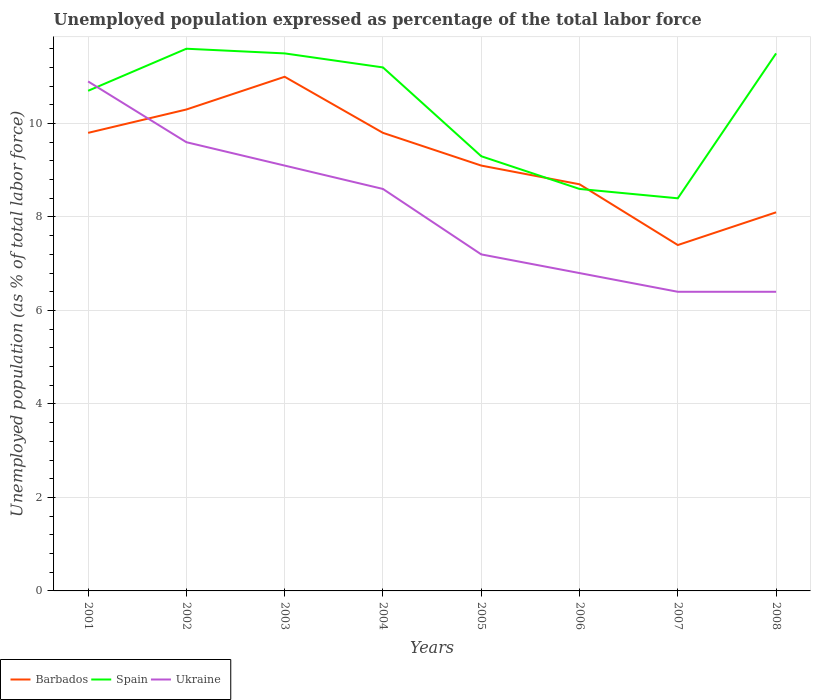How many different coloured lines are there?
Provide a succinct answer. 3. Does the line corresponding to Spain intersect with the line corresponding to Ukraine?
Give a very brief answer. Yes. Is the number of lines equal to the number of legend labels?
Your answer should be very brief. Yes. Across all years, what is the maximum unemployment in in Spain?
Provide a succinct answer. 8.4. What is the total unemployment in in Ukraine in the graph?
Ensure brevity in your answer.  4.5. What is the difference between the highest and the second highest unemployment in in Ukraine?
Your answer should be very brief. 4.5. What is the difference between two consecutive major ticks on the Y-axis?
Your answer should be compact. 2. Are the values on the major ticks of Y-axis written in scientific E-notation?
Offer a terse response. No. Does the graph contain any zero values?
Provide a succinct answer. No. Does the graph contain grids?
Your response must be concise. Yes. How are the legend labels stacked?
Offer a very short reply. Horizontal. What is the title of the graph?
Your response must be concise. Unemployed population expressed as percentage of the total labor force. Does "East Asia (developing only)" appear as one of the legend labels in the graph?
Provide a short and direct response. No. What is the label or title of the X-axis?
Give a very brief answer. Years. What is the label or title of the Y-axis?
Make the answer very short. Unemployed population (as % of total labor force). What is the Unemployed population (as % of total labor force) of Barbados in 2001?
Make the answer very short. 9.8. What is the Unemployed population (as % of total labor force) in Spain in 2001?
Your response must be concise. 10.7. What is the Unemployed population (as % of total labor force) of Ukraine in 2001?
Make the answer very short. 10.9. What is the Unemployed population (as % of total labor force) of Barbados in 2002?
Provide a succinct answer. 10.3. What is the Unemployed population (as % of total labor force) of Spain in 2002?
Give a very brief answer. 11.6. What is the Unemployed population (as % of total labor force) of Ukraine in 2002?
Your answer should be compact. 9.6. What is the Unemployed population (as % of total labor force) of Ukraine in 2003?
Offer a terse response. 9.1. What is the Unemployed population (as % of total labor force) of Barbados in 2004?
Your response must be concise. 9.8. What is the Unemployed population (as % of total labor force) in Spain in 2004?
Provide a succinct answer. 11.2. What is the Unemployed population (as % of total labor force) of Ukraine in 2004?
Give a very brief answer. 8.6. What is the Unemployed population (as % of total labor force) of Barbados in 2005?
Keep it short and to the point. 9.1. What is the Unemployed population (as % of total labor force) of Spain in 2005?
Provide a short and direct response. 9.3. What is the Unemployed population (as % of total labor force) in Ukraine in 2005?
Provide a succinct answer. 7.2. What is the Unemployed population (as % of total labor force) in Barbados in 2006?
Offer a terse response. 8.7. What is the Unemployed population (as % of total labor force) in Spain in 2006?
Provide a short and direct response. 8.6. What is the Unemployed population (as % of total labor force) of Ukraine in 2006?
Ensure brevity in your answer.  6.8. What is the Unemployed population (as % of total labor force) in Barbados in 2007?
Provide a succinct answer. 7.4. What is the Unemployed population (as % of total labor force) in Spain in 2007?
Make the answer very short. 8.4. What is the Unemployed population (as % of total labor force) in Ukraine in 2007?
Provide a short and direct response. 6.4. What is the Unemployed population (as % of total labor force) of Barbados in 2008?
Give a very brief answer. 8.1. What is the Unemployed population (as % of total labor force) in Ukraine in 2008?
Offer a terse response. 6.4. Across all years, what is the maximum Unemployed population (as % of total labor force) of Spain?
Your answer should be very brief. 11.6. Across all years, what is the maximum Unemployed population (as % of total labor force) in Ukraine?
Keep it short and to the point. 10.9. Across all years, what is the minimum Unemployed population (as % of total labor force) of Barbados?
Keep it short and to the point. 7.4. Across all years, what is the minimum Unemployed population (as % of total labor force) in Spain?
Your answer should be compact. 8.4. Across all years, what is the minimum Unemployed population (as % of total labor force) in Ukraine?
Make the answer very short. 6.4. What is the total Unemployed population (as % of total labor force) of Barbados in the graph?
Your answer should be very brief. 74.2. What is the total Unemployed population (as % of total labor force) in Spain in the graph?
Provide a short and direct response. 82.8. What is the difference between the Unemployed population (as % of total labor force) in Barbados in 2001 and that in 2002?
Offer a terse response. -0.5. What is the difference between the Unemployed population (as % of total labor force) of Spain in 2001 and that in 2002?
Your response must be concise. -0.9. What is the difference between the Unemployed population (as % of total labor force) in Ukraine in 2001 and that in 2002?
Provide a short and direct response. 1.3. What is the difference between the Unemployed population (as % of total labor force) of Barbados in 2001 and that in 2003?
Your response must be concise. -1.2. What is the difference between the Unemployed population (as % of total labor force) in Barbados in 2001 and that in 2004?
Provide a short and direct response. 0. What is the difference between the Unemployed population (as % of total labor force) of Spain in 2001 and that in 2004?
Provide a short and direct response. -0.5. What is the difference between the Unemployed population (as % of total labor force) of Barbados in 2001 and that in 2005?
Make the answer very short. 0.7. What is the difference between the Unemployed population (as % of total labor force) of Spain in 2001 and that in 2005?
Offer a terse response. 1.4. What is the difference between the Unemployed population (as % of total labor force) of Ukraine in 2001 and that in 2005?
Your response must be concise. 3.7. What is the difference between the Unemployed population (as % of total labor force) of Barbados in 2001 and that in 2006?
Provide a short and direct response. 1.1. What is the difference between the Unemployed population (as % of total labor force) in Spain in 2001 and that in 2006?
Ensure brevity in your answer.  2.1. What is the difference between the Unemployed population (as % of total labor force) in Ukraine in 2001 and that in 2007?
Make the answer very short. 4.5. What is the difference between the Unemployed population (as % of total labor force) in Ukraine in 2001 and that in 2008?
Offer a terse response. 4.5. What is the difference between the Unemployed population (as % of total labor force) in Spain in 2002 and that in 2003?
Offer a terse response. 0.1. What is the difference between the Unemployed population (as % of total labor force) in Barbados in 2002 and that in 2004?
Ensure brevity in your answer.  0.5. What is the difference between the Unemployed population (as % of total labor force) of Spain in 2002 and that in 2004?
Your answer should be compact. 0.4. What is the difference between the Unemployed population (as % of total labor force) in Ukraine in 2002 and that in 2004?
Offer a terse response. 1. What is the difference between the Unemployed population (as % of total labor force) in Spain in 2002 and that in 2005?
Your answer should be very brief. 2.3. What is the difference between the Unemployed population (as % of total labor force) of Ukraine in 2002 and that in 2005?
Your answer should be compact. 2.4. What is the difference between the Unemployed population (as % of total labor force) in Barbados in 2002 and that in 2006?
Your response must be concise. 1.6. What is the difference between the Unemployed population (as % of total labor force) of Ukraine in 2002 and that in 2006?
Offer a very short reply. 2.8. What is the difference between the Unemployed population (as % of total labor force) of Spain in 2002 and that in 2007?
Give a very brief answer. 3.2. What is the difference between the Unemployed population (as % of total labor force) of Ukraine in 2002 and that in 2007?
Keep it short and to the point. 3.2. What is the difference between the Unemployed population (as % of total labor force) in Spain in 2002 and that in 2008?
Provide a succinct answer. 0.1. What is the difference between the Unemployed population (as % of total labor force) in Ukraine in 2003 and that in 2004?
Provide a short and direct response. 0.5. What is the difference between the Unemployed population (as % of total labor force) of Barbados in 2003 and that in 2005?
Provide a succinct answer. 1.9. What is the difference between the Unemployed population (as % of total labor force) of Ukraine in 2003 and that in 2006?
Ensure brevity in your answer.  2.3. What is the difference between the Unemployed population (as % of total labor force) of Ukraine in 2003 and that in 2007?
Give a very brief answer. 2.7. What is the difference between the Unemployed population (as % of total labor force) in Ukraine in 2003 and that in 2008?
Provide a succinct answer. 2.7. What is the difference between the Unemployed population (as % of total labor force) in Barbados in 2004 and that in 2006?
Give a very brief answer. 1.1. What is the difference between the Unemployed population (as % of total labor force) in Spain in 2004 and that in 2006?
Offer a terse response. 2.6. What is the difference between the Unemployed population (as % of total labor force) in Barbados in 2004 and that in 2007?
Your answer should be compact. 2.4. What is the difference between the Unemployed population (as % of total labor force) of Spain in 2004 and that in 2007?
Keep it short and to the point. 2.8. What is the difference between the Unemployed population (as % of total labor force) in Barbados in 2004 and that in 2008?
Offer a terse response. 1.7. What is the difference between the Unemployed population (as % of total labor force) in Ukraine in 2004 and that in 2008?
Keep it short and to the point. 2.2. What is the difference between the Unemployed population (as % of total labor force) in Spain in 2005 and that in 2006?
Give a very brief answer. 0.7. What is the difference between the Unemployed population (as % of total labor force) of Ukraine in 2005 and that in 2007?
Provide a short and direct response. 0.8. What is the difference between the Unemployed population (as % of total labor force) in Barbados in 2006 and that in 2008?
Provide a short and direct response. 0.6. What is the difference between the Unemployed population (as % of total labor force) in Ukraine in 2006 and that in 2008?
Offer a terse response. 0.4. What is the difference between the Unemployed population (as % of total labor force) in Barbados in 2007 and that in 2008?
Offer a very short reply. -0.7. What is the difference between the Unemployed population (as % of total labor force) of Spain in 2007 and that in 2008?
Provide a short and direct response. -3.1. What is the difference between the Unemployed population (as % of total labor force) in Barbados in 2001 and the Unemployed population (as % of total labor force) in Spain in 2002?
Offer a terse response. -1.8. What is the difference between the Unemployed population (as % of total labor force) in Barbados in 2001 and the Unemployed population (as % of total labor force) in Ukraine in 2003?
Keep it short and to the point. 0.7. What is the difference between the Unemployed population (as % of total labor force) in Spain in 2001 and the Unemployed population (as % of total labor force) in Ukraine in 2003?
Offer a very short reply. 1.6. What is the difference between the Unemployed population (as % of total labor force) in Barbados in 2001 and the Unemployed population (as % of total labor force) in Ukraine in 2004?
Your response must be concise. 1.2. What is the difference between the Unemployed population (as % of total labor force) in Spain in 2001 and the Unemployed population (as % of total labor force) in Ukraine in 2004?
Give a very brief answer. 2.1. What is the difference between the Unemployed population (as % of total labor force) in Barbados in 2001 and the Unemployed population (as % of total labor force) in Spain in 2005?
Ensure brevity in your answer.  0.5. What is the difference between the Unemployed population (as % of total labor force) in Barbados in 2001 and the Unemployed population (as % of total labor force) in Ukraine in 2005?
Your answer should be very brief. 2.6. What is the difference between the Unemployed population (as % of total labor force) of Spain in 2001 and the Unemployed population (as % of total labor force) of Ukraine in 2005?
Your answer should be very brief. 3.5. What is the difference between the Unemployed population (as % of total labor force) of Spain in 2001 and the Unemployed population (as % of total labor force) of Ukraine in 2006?
Keep it short and to the point. 3.9. What is the difference between the Unemployed population (as % of total labor force) of Spain in 2001 and the Unemployed population (as % of total labor force) of Ukraine in 2007?
Offer a very short reply. 4.3. What is the difference between the Unemployed population (as % of total labor force) in Barbados in 2001 and the Unemployed population (as % of total labor force) in Ukraine in 2008?
Give a very brief answer. 3.4. What is the difference between the Unemployed population (as % of total labor force) of Barbados in 2002 and the Unemployed population (as % of total labor force) of Ukraine in 2003?
Give a very brief answer. 1.2. What is the difference between the Unemployed population (as % of total labor force) in Barbados in 2002 and the Unemployed population (as % of total labor force) in Spain in 2004?
Your answer should be very brief. -0.9. What is the difference between the Unemployed population (as % of total labor force) of Barbados in 2002 and the Unemployed population (as % of total labor force) of Ukraine in 2004?
Offer a very short reply. 1.7. What is the difference between the Unemployed population (as % of total labor force) of Spain in 2002 and the Unemployed population (as % of total labor force) of Ukraine in 2004?
Offer a very short reply. 3. What is the difference between the Unemployed population (as % of total labor force) of Barbados in 2002 and the Unemployed population (as % of total labor force) of Spain in 2005?
Your answer should be compact. 1. What is the difference between the Unemployed population (as % of total labor force) of Spain in 2002 and the Unemployed population (as % of total labor force) of Ukraine in 2005?
Offer a very short reply. 4.4. What is the difference between the Unemployed population (as % of total labor force) of Barbados in 2002 and the Unemployed population (as % of total labor force) of Ukraine in 2006?
Ensure brevity in your answer.  3.5. What is the difference between the Unemployed population (as % of total labor force) in Spain in 2002 and the Unemployed population (as % of total labor force) in Ukraine in 2007?
Your answer should be very brief. 5.2. What is the difference between the Unemployed population (as % of total labor force) of Barbados in 2002 and the Unemployed population (as % of total labor force) of Ukraine in 2008?
Your answer should be very brief. 3.9. What is the difference between the Unemployed population (as % of total labor force) of Spain in 2002 and the Unemployed population (as % of total labor force) of Ukraine in 2008?
Keep it short and to the point. 5.2. What is the difference between the Unemployed population (as % of total labor force) in Barbados in 2003 and the Unemployed population (as % of total labor force) in Ukraine in 2004?
Your answer should be compact. 2.4. What is the difference between the Unemployed population (as % of total labor force) of Spain in 2003 and the Unemployed population (as % of total labor force) of Ukraine in 2004?
Your response must be concise. 2.9. What is the difference between the Unemployed population (as % of total labor force) of Barbados in 2003 and the Unemployed population (as % of total labor force) of Spain in 2005?
Ensure brevity in your answer.  1.7. What is the difference between the Unemployed population (as % of total labor force) of Barbados in 2003 and the Unemployed population (as % of total labor force) of Ukraine in 2005?
Offer a very short reply. 3.8. What is the difference between the Unemployed population (as % of total labor force) in Spain in 2003 and the Unemployed population (as % of total labor force) in Ukraine in 2005?
Give a very brief answer. 4.3. What is the difference between the Unemployed population (as % of total labor force) of Barbados in 2003 and the Unemployed population (as % of total labor force) of Spain in 2006?
Your answer should be compact. 2.4. What is the difference between the Unemployed population (as % of total labor force) of Spain in 2003 and the Unemployed population (as % of total labor force) of Ukraine in 2006?
Make the answer very short. 4.7. What is the difference between the Unemployed population (as % of total labor force) of Barbados in 2003 and the Unemployed population (as % of total labor force) of Ukraine in 2007?
Give a very brief answer. 4.6. What is the difference between the Unemployed population (as % of total labor force) of Barbados in 2003 and the Unemployed population (as % of total labor force) of Spain in 2008?
Offer a very short reply. -0.5. What is the difference between the Unemployed population (as % of total labor force) in Barbados in 2003 and the Unemployed population (as % of total labor force) in Ukraine in 2008?
Your answer should be very brief. 4.6. What is the difference between the Unemployed population (as % of total labor force) of Barbados in 2004 and the Unemployed population (as % of total labor force) of Ukraine in 2005?
Offer a very short reply. 2.6. What is the difference between the Unemployed population (as % of total labor force) of Barbados in 2004 and the Unemployed population (as % of total labor force) of Ukraine in 2006?
Your response must be concise. 3. What is the difference between the Unemployed population (as % of total labor force) of Spain in 2004 and the Unemployed population (as % of total labor force) of Ukraine in 2006?
Ensure brevity in your answer.  4.4. What is the difference between the Unemployed population (as % of total labor force) in Barbados in 2004 and the Unemployed population (as % of total labor force) in Spain in 2007?
Keep it short and to the point. 1.4. What is the difference between the Unemployed population (as % of total labor force) in Barbados in 2004 and the Unemployed population (as % of total labor force) in Ukraine in 2007?
Keep it short and to the point. 3.4. What is the difference between the Unemployed population (as % of total labor force) of Spain in 2004 and the Unemployed population (as % of total labor force) of Ukraine in 2007?
Offer a very short reply. 4.8. What is the difference between the Unemployed population (as % of total labor force) in Barbados in 2004 and the Unemployed population (as % of total labor force) in Ukraine in 2008?
Make the answer very short. 3.4. What is the difference between the Unemployed population (as % of total labor force) in Spain in 2004 and the Unemployed population (as % of total labor force) in Ukraine in 2008?
Provide a succinct answer. 4.8. What is the difference between the Unemployed population (as % of total labor force) in Barbados in 2005 and the Unemployed population (as % of total labor force) in Ukraine in 2006?
Your answer should be compact. 2.3. What is the difference between the Unemployed population (as % of total labor force) of Barbados in 2005 and the Unemployed population (as % of total labor force) of Spain in 2007?
Offer a terse response. 0.7. What is the difference between the Unemployed population (as % of total labor force) of Barbados in 2005 and the Unemployed population (as % of total labor force) of Ukraine in 2007?
Offer a terse response. 2.7. What is the difference between the Unemployed population (as % of total labor force) in Spain in 2005 and the Unemployed population (as % of total labor force) in Ukraine in 2007?
Ensure brevity in your answer.  2.9. What is the difference between the Unemployed population (as % of total labor force) in Barbados in 2005 and the Unemployed population (as % of total labor force) in Ukraine in 2008?
Your answer should be compact. 2.7. What is the difference between the Unemployed population (as % of total labor force) of Spain in 2006 and the Unemployed population (as % of total labor force) of Ukraine in 2007?
Your answer should be very brief. 2.2. What is the difference between the Unemployed population (as % of total labor force) of Barbados in 2007 and the Unemployed population (as % of total labor force) of Spain in 2008?
Make the answer very short. -4.1. What is the difference between the Unemployed population (as % of total labor force) of Barbados in 2007 and the Unemployed population (as % of total labor force) of Ukraine in 2008?
Provide a succinct answer. 1. What is the average Unemployed population (as % of total labor force) of Barbados per year?
Offer a very short reply. 9.28. What is the average Unemployed population (as % of total labor force) of Spain per year?
Your response must be concise. 10.35. What is the average Unemployed population (as % of total labor force) of Ukraine per year?
Keep it short and to the point. 8.12. In the year 2002, what is the difference between the Unemployed population (as % of total labor force) in Barbados and Unemployed population (as % of total labor force) in Ukraine?
Keep it short and to the point. 0.7. In the year 2003, what is the difference between the Unemployed population (as % of total labor force) of Spain and Unemployed population (as % of total labor force) of Ukraine?
Your response must be concise. 2.4. In the year 2004, what is the difference between the Unemployed population (as % of total labor force) in Barbados and Unemployed population (as % of total labor force) in Ukraine?
Make the answer very short. 1.2. In the year 2004, what is the difference between the Unemployed population (as % of total labor force) in Spain and Unemployed population (as % of total labor force) in Ukraine?
Keep it short and to the point. 2.6. In the year 2005, what is the difference between the Unemployed population (as % of total labor force) in Barbados and Unemployed population (as % of total labor force) in Spain?
Offer a terse response. -0.2. In the year 2006, what is the difference between the Unemployed population (as % of total labor force) in Barbados and Unemployed population (as % of total labor force) in Spain?
Provide a succinct answer. 0.1. In the year 2006, what is the difference between the Unemployed population (as % of total labor force) of Spain and Unemployed population (as % of total labor force) of Ukraine?
Give a very brief answer. 1.8. In the year 2007, what is the difference between the Unemployed population (as % of total labor force) of Barbados and Unemployed population (as % of total labor force) of Spain?
Offer a terse response. -1. In the year 2008, what is the difference between the Unemployed population (as % of total labor force) in Barbados and Unemployed population (as % of total labor force) in Spain?
Provide a short and direct response. -3.4. In the year 2008, what is the difference between the Unemployed population (as % of total labor force) in Spain and Unemployed population (as % of total labor force) in Ukraine?
Ensure brevity in your answer.  5.1. What is the ratio of the Unemployed population (as % of total labor force) of Barbados in 2001 to that in 2002?
Your response must be concise. 0.95. What is the ratio of the Unemployed population (as % of total labor force) in Spain in 2001 to that in 2002?
Provide a succinct answer. 0.92. What is the ratio of the Unemployed population (as % of total labor force) of Ukraine in 2001 to that in 2002?
Provide a succinct answer. 1.14. What is the ratio of the Unemployed population (as % of total labor force) in Barbados in 2001 to that in 2003?
Ensure brevity in your answer.  0.89. What is the ratio of the Unemployed population (as % of total labor force) in Spain in 2001 to that in 2003?
Keep it short and to the point. 0.93. What is the ratio of the Unemployed population (as % of total labor force) in Ukraine in 2001 to that in 2003?
Provide a short and direct response. 1.2. What is the ratio of the Unemployed population (as % of total labor force) of Spain in 2001 to that in 2004?
Offer a very short reply. 0.96. What is the ratio of the Unemployed population (as % of total labor force) in Ukraine in 2001 to that in 2004?
Offer a terse response. 1.27. What is the ratio of the Unemployed population (as % of total labor force) of Barbados in 2001 to that in 2005?
Your answer should be compact. 1.08. What is the ratio of the Unemployed population (as % of total labor force) in Spain in 2001 to that in 2005?
Keep it short and to the point. 1.15. What is the ratio of the Unemployed population (as % of total labor force) of Ukraine in 2001 to that in 2005?
Provide a short and direct response. 1.51. What is the ratio of the Unemployed population (as % of total labor force) in Barbados in 2001 to that in 2006?
Keep it short and to the point. 1.13. What is the ratio of the Unemployed population (as % of total labor force) of Spain in 2001 to that in 2006?
Make the answer very short. 1.24. What is the ratio of the Unemployed population (as % of total labor force) in Ukraine in 2001 to that in 2006?
Your response must be concise. 1.6. What is the ratio of the Unemployed population (as % of total labor force) in Barbados in 2001 to that in 2007?
Your answer should be very brief. 1.32. What is the ratio of the Unemployed population (as % of total labor force) of Spain in 2001 to that in 2007?
Offer a very short reply. 1.27. What is the ratio of the Unemployed population (as % of total labor force) in Ukraine in 2001 to that in 2007?
Provide a short and direct response. 1.7. What is the ratio of the Unemployed population (as % of total labor force) of Barbados in 2001 to that in 2008?
Your answer should be very brief. 1.21. What is the ratio of the Unemployed population (as % of total labor force) in Spain in 2001 to that in 2008?
Provide a succinct answer. 0.93. What is the ratio of the Unemployed population (as % of total labor force) of Ukraine in 2001 to that in 2008?
Offer a terse response. 1.7. What is the ratio of the Unemployed population (as % of total labor force) of Barbados in 2002 to that in 2003?
Give a very brief answer. 0.94. What is the ratio of the Unemployed population (as % of total labor force) of Spain in 2002 to that in 2003?
Offer a very short reply. 1.01. What is the ratio of the Unemployed population (as % of total labor force) of Ukraine in 2002 to that in 2003?
Keep it short and to the point. 1.05. What is the ratio of the Unemployed population (as % of total labor force) of Barbados in 2002 to that in 2004?
Provide a succinct answer. 1.05. What is the ratio of the Unemployed population (as % of total labor force) in Spain in 2002 to that in 2004?
Keep it short and to the point. 1.04. What is the ratio of the Unemployed population (as % of total labor force) in Ukraine in 2002 to that in 2004?
Provide a succinct answer. 1.12. What is the ratio of the Unemployed population (as % of total labor force) in Barbados in 2002 to that in 2005?
Your response must be concise. 1.13. What is the ratio of the Unemployed population (as % of total labor force) in Spain in 2002 to that in 2005?
Offer a terse response. 1.25. What is the ratio of the Unemployed population (as % of total labor force) in Barbados in 2002 to that in 2006?
Keep it short and to the point. 1.18. What is the ratio of the Unemployed population (as % of total labor force) of Spain in 2002 to that in 2006?
Offer a very short reply. 1.35. What is the ratio of the Unemployed population (as % of total labor force) in Ukraine in 2002 to that in 2006?
Provide a succinct answer. 1.41. What is the ratio of the Unemployed population (as % of total labor force) of Barbados in 2002 to that in 2007?
Offer a very short reply. 1.39. What is the ratio of the Unemployed population (as % of total labor force) of Spain in 2002 to that in 2007?
Your answer should be compact. 1.38. What is the ratio of the Unemployed population (as % of total labor force) of Barbados in 2002 to that in 2008?
Offer a very short reply. 1.27. What is the ratio of the Unemployed population (as % of total labor force) in Spain in 2002 to that in 2008?
Provide a succinct answer. 1.01. What is the ratio of the Unemployed population (as % of total labor force) of Ukraine in 2002 to that in 2008?
Provide a succinct answer. 1.5. What is the ratio of the Unemployed population (as % of total labor force) in Barbados in 2003 to that in 2004?
Keep it short and to the point. 1.12. What is the ratio of the Unemployed population (as % of total labor force) of Spain in 2003 to that in 2004?
Your response must be concise. 1.03. What is the ratio of the Unemployed population (as % of total labor force) in Ukraine in 2003 to that in 2004?
Offer a terse response. 1.06. What is the ratio of the Unemployed population (as % of total labor force) of Barbados in 2003 to that in 2005?
Your answer should be compact. 1.21. What is the ratio of the Unemployed population (as % of total labor force) of Spain in 2003 to that in 2005?
Give a very brief answer. 1.24. What is the ratio of the Unemployed population (as % of total labor force) in Ukraine in 2003 to that in 2005?
Give a very brief answer. 1.26. What is the ratio of the Unemployed population (as % of total labor force) of Barbados in 2003 to that in 2006?
Keep it short and to the point. 1.26. What is the ratio of the Unemployed population (as % of total labor force) in Spain in 2003 to that in 2006?
Your answer should be compact. 1.34. What is the ratio of the Unemployed population (as % of total labor force) in Ukraine in 2003 to that in 2006?
Provide a succinct answer. 1.34. What is the ratio of the Unemployed population (as % of total labor force) of Barbados in 2003 to that in 2007?
Your answer should be very brief. 1.49. What is the ratio of the Unemployed population (as % of total labor force) in Spain in 2003 to that in 2007?
Your answer should be very brief. 1.37. What is the ratio of the Unemployed population (as % of total labor force) in Ukraine in 2003 to that in 2007?
Provide a succinct answer. 1.42. What is the ratio of the Unemployed population (as % of total labor force) in Barbados in 2003 to that in 2008?
Ensure brevity in your answer.  1.36. What is the ratio of the Unemployed population (as % of total labor force) of Spain in 2003 to that in 2008?
Your response must be concise. 1. What is the ratio of the Unemployed population (as % of total labor force) in Ukraine in 2003 to that in 2008?
Your answer should be compact. 1.42. What is the ratio of the Unemployed population (as % of total labor force) of Barbados in 2004 to that in 2005?
Your answer should be compact. 1.08. What is the ratio of the Unemployed population (as % of total labor force) of Spain in 2004 to that in 2005?
Offer a very short reply. 1.2. What is the ratio of the Unemployed population (as % of total labor force) in Ukraine in 2004 to that in 2005?
Keep it short and to the point. 1.19. What is the ratio of the Unemployed population (as % of total labor force) of Barbados in 2004 to that in 2006?
Your answer should be compact. 1.13. What is the ratio of the Unemployed population (as % of total labor force) of Spain in 2004 to that in 2006?
Offer a very short reply. 1.3. What is the ratio of the Unemployed population (as % of total labor force) in Ukraine in 2004 to that in 2006?
Your response must be concise. 1.26. What is the ratio of the Unemployed population (as % of total labor force) in Barbados in 2004 to that in 2007?
Your response must be concise. 1.32. What is the ratio of the Unemployed population (as % of total labor force) of Spain in 2004 to that in 2007?
Your answer should be very brief. 1.33. What is the ratio of the Unemployed population (as % of total labor force) in Ukraine in 2004 to that in 2007?
Ensure brevity in your answer.  1.34. What is the ratio of the Unemployed population (as % of total labor force) in Barbados in 2004 to that in 2008?
Your answer should be very brief. 1.21. What is the ratio of the Unemployed population (as % of total labor force) in Spain in 2004 to that in 2008?
Give a very brief answer. 0.97. What is the ratio of the Unemployed population (as % of total labor force) of Ukraine in 2004 to that in 2008?
Your answer should be very brief. 1.34. What is the ratio of the Unemployed population (as % of total labor force) in Barbados in 2005 to that in 2006?
Your response must be concise. 1.05. What is the ratio of the Unemployed population (as % of total labor force) of Spain in 2005 to that in 2006?
Your response must be concise. 1.08. What is the ratio of the Unemployed population (as % of total labor force) of Ukraine in 2005 to that in 2006?
Your response must be concise. 1.06. What is the ratio of the Unemployed population (as % of total labor force) in Barbados in 2005 to that in 2007?
Your answer should be very brief. 1.23. What is the ratio of the Unemployed population (as % of total labor force) in Spain in 2005 to that in 2007?
Offer a terse response. 1.11. What is the ratio of the Unemployed population (as % of total labor force) in Barbados in 2005 to that in 2008?
Ensure brevity in your answer.  1.12. What is the ratio of the Unemployed population (as % of total labor force) of Spain in 2005 to that in 2008?
Offer a very short reply. 0.81. What is the ratio of the Unemployed population (as % of total labor force) in Barbados in 2006 to that in 2007?
Your answer should be compact. 1.18. What is the ratio of the Unemployed population (as % of total labor force) of Spain in 2006 to that in 2007?
Your answer should be very brief. 1.02. What is the ratio of the Unemployed population (as % of total labor force) in Ukraine in 2006 to that in 2007?
Your answer should be very brief. 1.06. What is the ratio of the Unemployed population (as % of total labor force) in Barbados in 2006 to that in 2008?
Make the answer very short. 1.07. What is the ratio of the Unemployed population (as % of total labor force) of Spain in 2006 to that in 2008?
Ensure brevity in your answer.  0.75. What is the ratio of the Unemployed population (as % of total labor force) in Ukraine in 2006 to that in 2008?
Ensure brevity in your answer.  1.06. What is the ratio of the Unemployed population (as % of total labor force) of Barbados in 2007 to that in 2008?
Offer a very short reply. 0.91. What is the ratio of the Unemployed population (as % of total labor force) in Spain in 2007 to that in 2008?
Offer a very short reply. 0.73. 